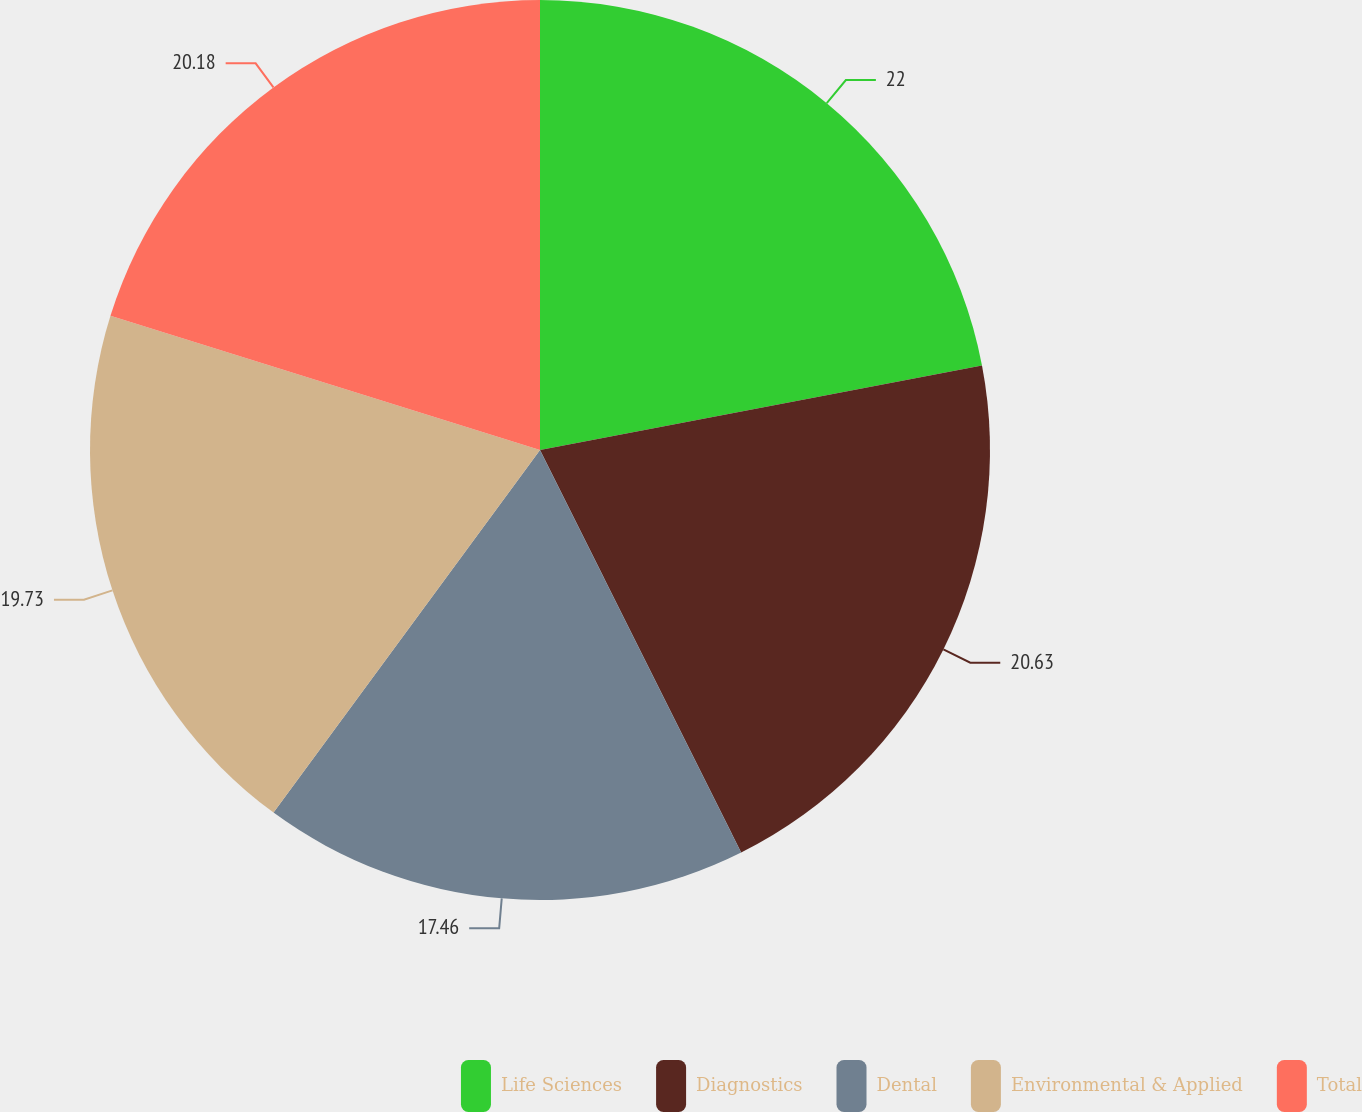<chart> <loc_0><loc_0><loc_500><loc_500><pie_chart><fcel>Life Sciences<fcel>Diagnostics<fcel>Dental<fcel>Environmental & Applied<fcel>Total<nl><fcel>21.99%<fcel>20.63%<fcel>17.46%<fcel>19.73%<fcel>20.18%<nl></chart> 